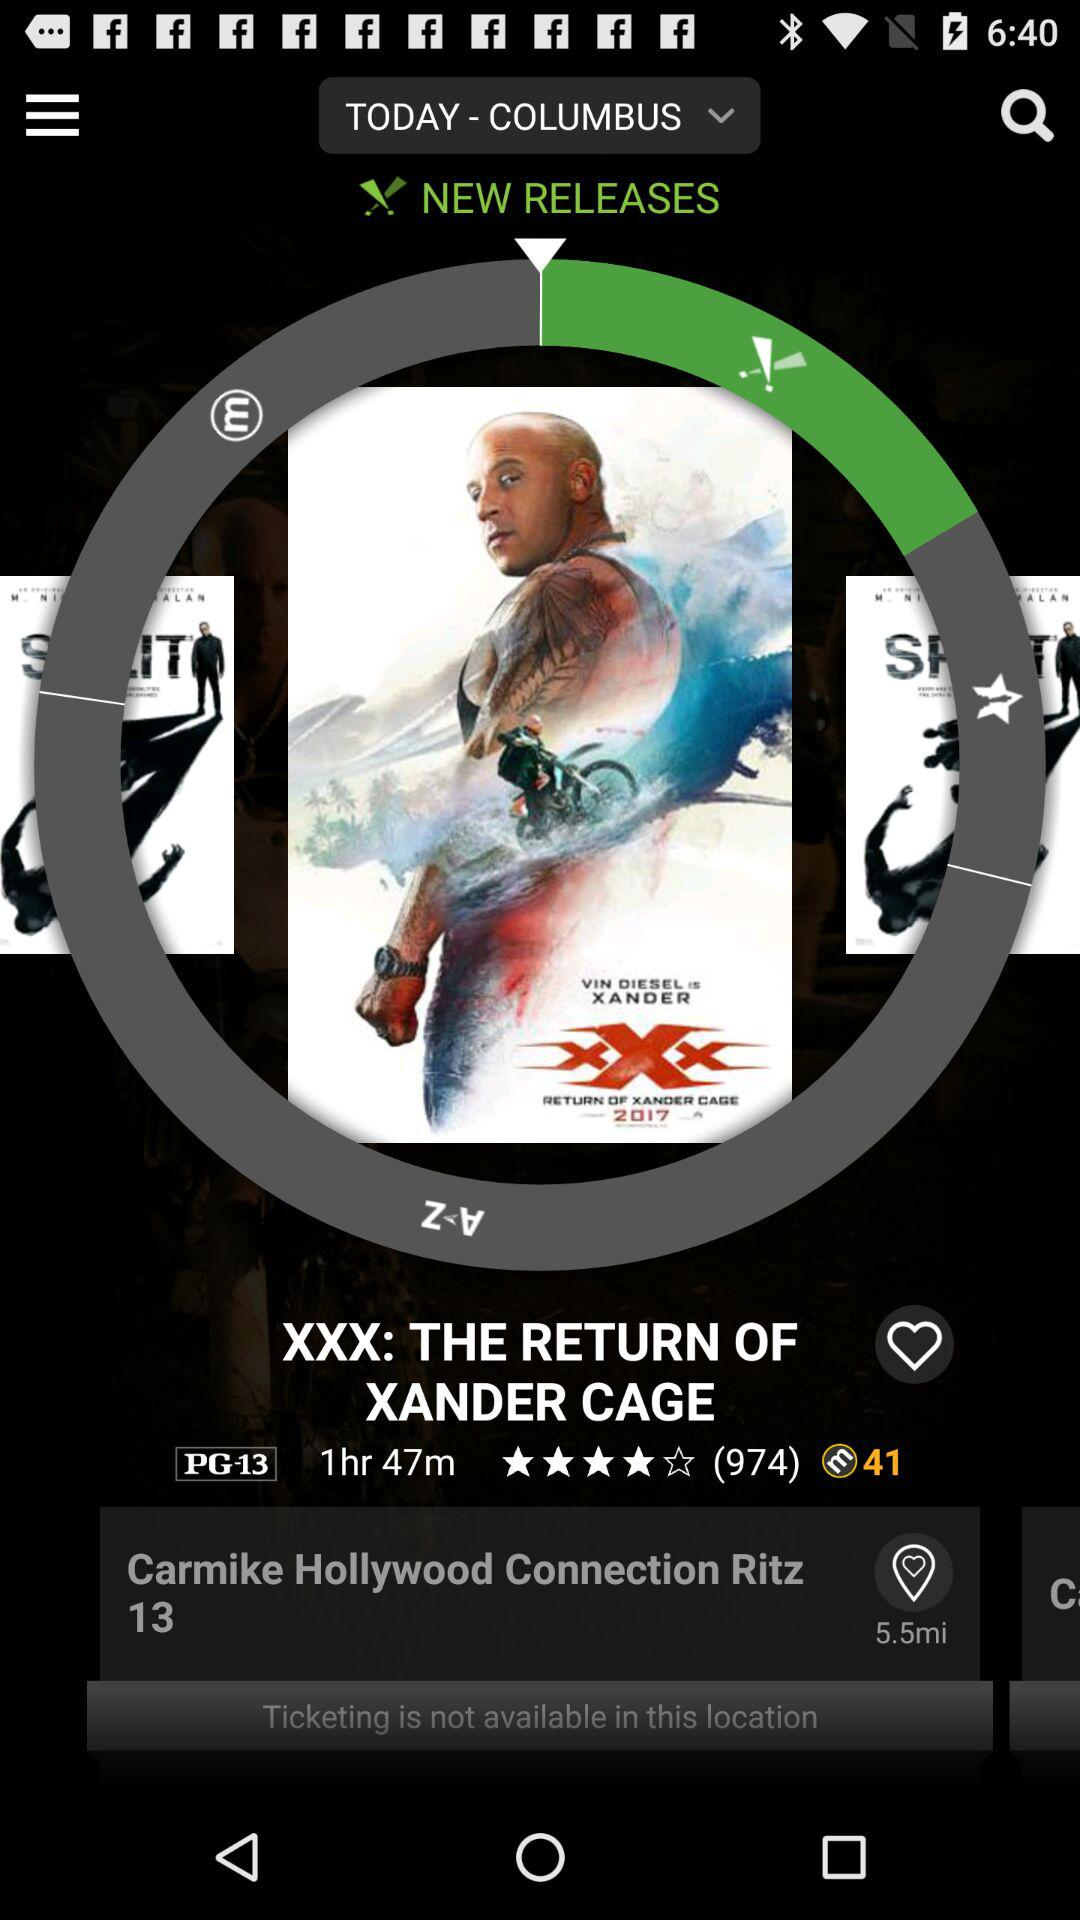What is the time duration of the new release in hours and minutes? The time duration is 1 hour 47 minutes. 